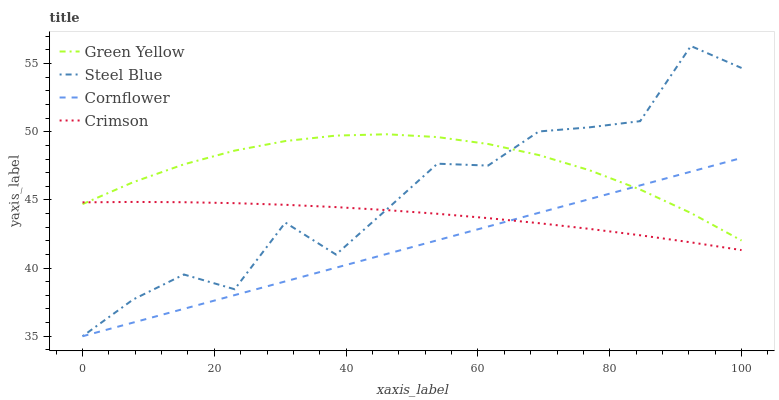Does Cornflower have the minimum area under the curve?
Answer yes or no. Yes. Does Green Yellow have the maximum area under the curve?
Answer yes or no. Yes. Does Green Yellow have the minimum area under the curve?
Answer yes or no. No. Does Cornflower have the maximum area under the curve?
Answer yes or no. No. Is Cornflower the smoothest?
Answer yes or no. Yes. Is Steel Blue the roughest?
Answer yes or no. Yes. Is Green Yellow the smoothest?
Answer yes or no. No. Is Green Yellow the roughest?
Answer yes or no. No. Does Cornflower have the lowest value?
Answer yes or no. Yes. Does Green Yellow have the lowest value?
Answer yes or no. No. Does Steel Blue have the highest value?
Answer yes or no. Yes. Does Cornflower have the highest value?
Answer yes or no. No. Does Crimson intersect Steel Blue?
Answer yes or no. Yes. Is Crimson less than Steel Blue?
Answer yes or no. No. Is Crimson greater than Steel Blue?
Answer yes or no. No. 